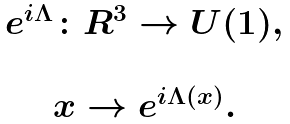Convert formula to latex. <formula><loc_0><loc_0><loc_500><loc_500>\begin{array} { c } e ^ { i \Lambda } \colon { R } ^ { 3 } \rightarrow U ( 1 ) , \\ \\ x \rightarrow e ^ { i \Lambda ( x ) } . \end{array}</formula> 